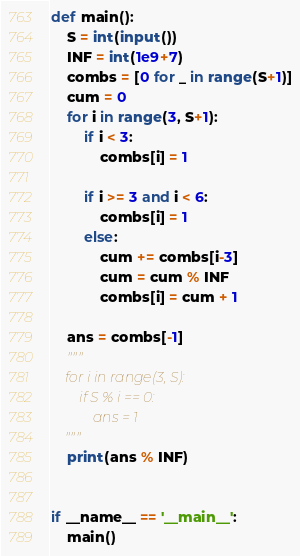<code> <loc_0><loc_0><loc_500><loc_500><_Python_>def main():
    S = int(input())
    INF = int(1e9+7)
    combs = [0 for _ in range(S+1)]
    cum = 0
    for i in range(3, S+1):
        if i < 3:
            combs[i] = 1

        if i >= 3 and i < 6:
            combs[i] = 1
        else:
            cum += combs[i-3]
            cum = cum % INF
            combs[i] = cum + 1

    ans = combs[-1]
    """
    for i in range(3, S):
        if S % i == 0:
            ans = 1
    """
    print(ans % INF)
    
    
if __name__ == '__main__':
    main()</code> 